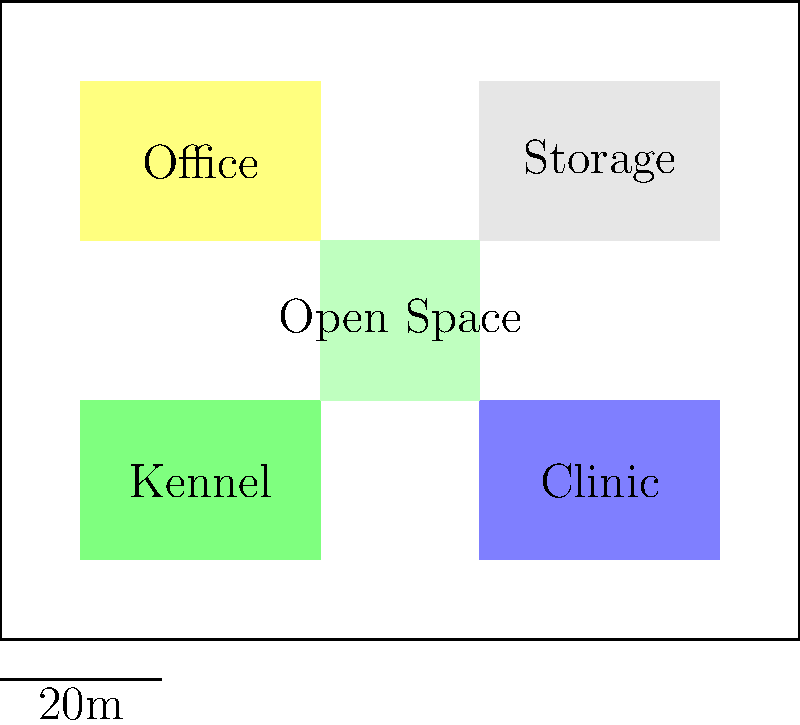Given the layout of a multi-functional animal rescue center shown above, which area is most suitable for conducting outdoor training sessions for rescued dogs, considering the need for space and minimal disturbance to other center activities? To determine the most suitable area for outdoor training sessions, let's analyze the layout:

1. Kennel: Located in the bottom-left corner, it's where rescued animals are housed. It's not ideal for training as it may disturb other animals.

2. Clinic: Situated in the bottom-right corner, it's for medical treatments. Training near here could stress sick animals and interfere with medical procedures.

3. Office: In the top-left corner, it's for administrative work. Training here might disrupt office activities.

4. Storage: In the top-right corner, it's for supplies. This area is likely not spacious enough for training.

5. Open Space: Located in the center of the layout, this area offers several advantages:
   a) It's centrally located, allowing easy access from all other areas.
   b) It provides sufficient space for training activities.
   c) It's separated from the kennel, clinic, office, and storage, minimizing disturbances.
   d) Its central location allows staff to monitor activities easily.

Given these considerations, the Open Space in the center is the most suitable area for conducting outdoor training sessions for rescued dogs. It offers the necessary space while minimizing potential disturbances to other center activities.
Answer: Open Space 